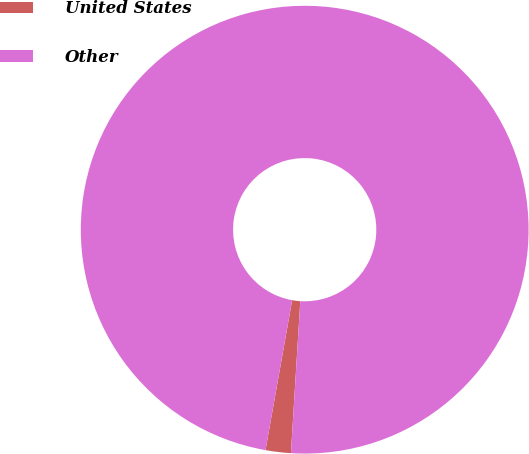<chart> <loc_0><loc_0><loc_500><loc_500><pie_chart><fcel>United States<fcel>Other<nl><fcel>1.82%<fcel>98.18%<nl></chart> 